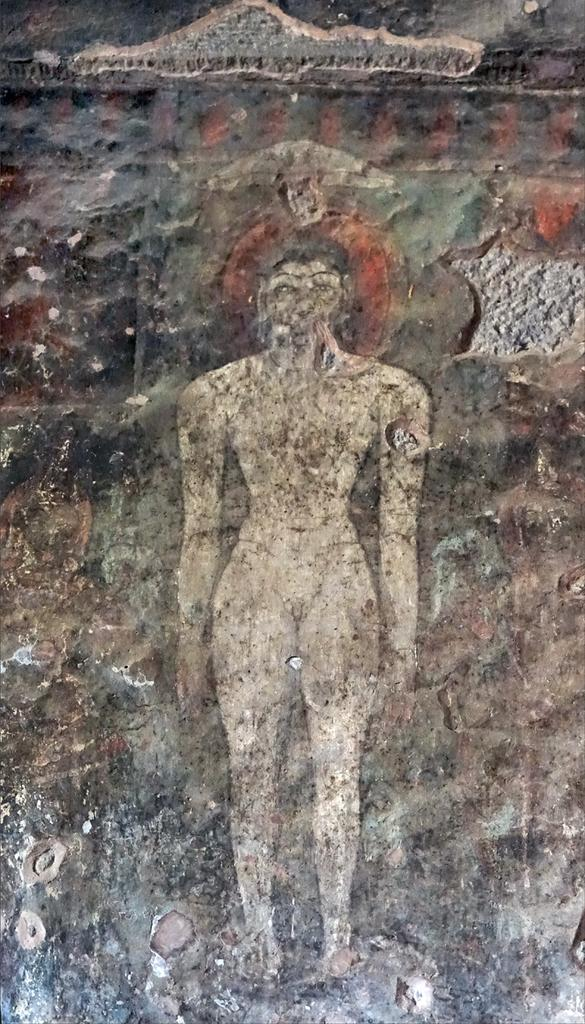What is present on the wall in the image? There is a painting of a human on the wall in the image. Can you describe the painting on the wall? The painting on the wall is of a human. What type of insect can be seen in the painting on the wall? There is no insect present in the painting on the wall; it is a painting of a human. 